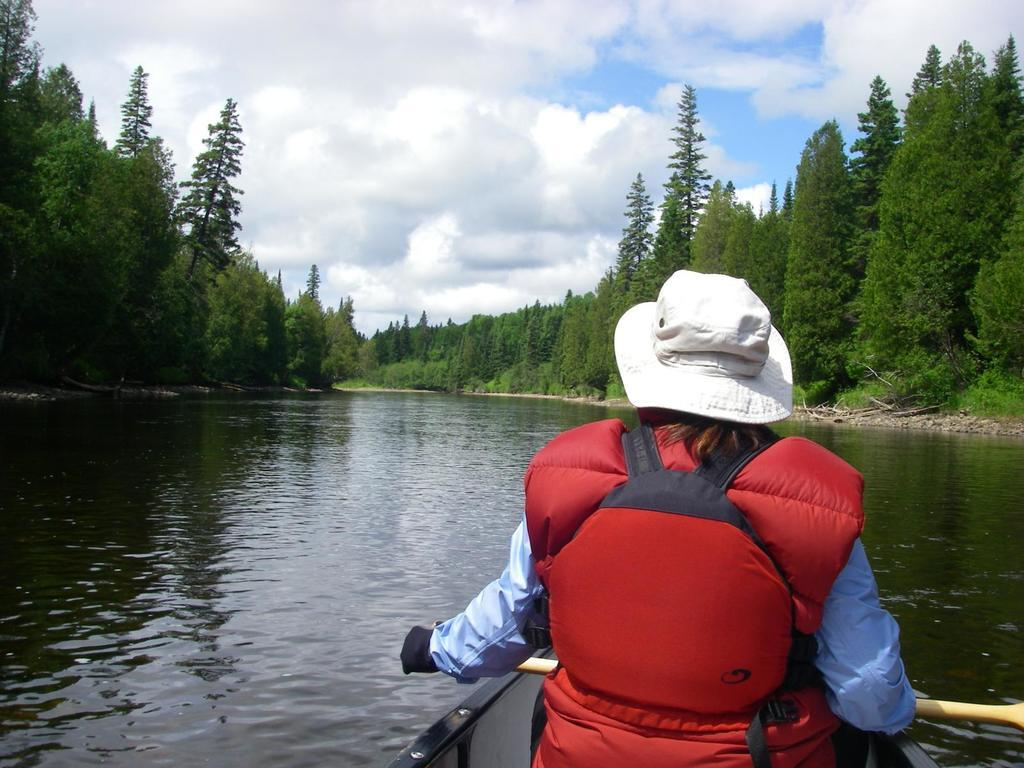What is the main subject in the foreground of the image? There is a person in the foreground of the image. What protective gear is the person wearing? The person is wearing a life jacket. What type of headwear is the person wearing? The person is wearing a hat. What is the person sitting on in the image? The person is sitting on a boat. What is the person holding in the image? The person is holding a paddle. What can be seen in the background of the image? There is water, trees, and sky visible in the background. What is the condition of the sky in the image? There are clouds visible in the sky. How many balls are being juggled by the person in the image? There are no balls present in the image; the person is holding a paddle and sitting on a boat. What mathematical operation is being performed by the person in the image? There is no indication of any mathematical operation being performed in the image. 